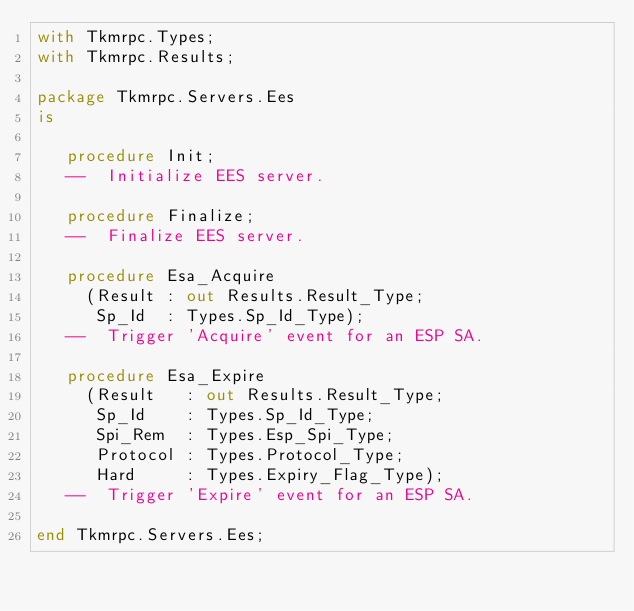Convert code to text. <code><loc_0><loc_0><loc_500><loc_500><_Ada_>with Tkmrpc.Types;
with Tkmrpc.Results;

package Tkmrpc.Servers.Ees
is

   procedure Init;
   --  Initialize EES server.

   procedure Finalize;
   --  Finalize EES server.

   procedure Esa_Acquire
     (Result : out Results.Result_Type;
      Sp_Id  : Types.Sp_Id_Type);
   --  Trigger 'Acquire' event for an ESP SA.

   procedure Esa_Expire
     (Result   : out Results.Result_Type;
      Sp_Id    : Types.Sp_Id_Type;
      Spi_Rem  : Types.Esp_Spi_Type;
      Protocol : Types.Protocol_Type;
      Hard     : Types.Expiry_Flag_Type);
   --  Trigger 'Expire' event for an ESP SA.

end Tkmrpc.Servers.Ees;
</code> 